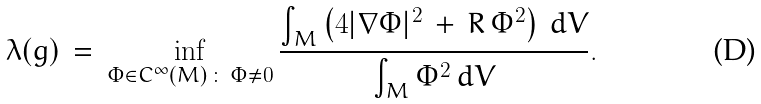<formula> <loc_0><loc_0><loc_500><loc_500>\lambda ( g ) \, = \, \inf _ { \Phi \in C ^ { \infty } ( M ) \, \colon \, \Phi \neq 0 } \frac { \int _ { M } \left ( 4 | \nabla \Phi | ^ { 2 } \, + \, R \, \Phi ^ { 2 } \right ) \, d V } { \int _ { M } \Phi ^ { 2 } \, d V } .</formula> 